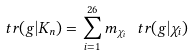<formula> <loc_0><loc_0><loc_500><loc_500>\ t r ( g | K _ { n } ) = \sum _ { i = 1 } ^ { 2 6 } m _ { \chi _ { i } } \, \ t r ( g | \chi _ { i } )</formula> 